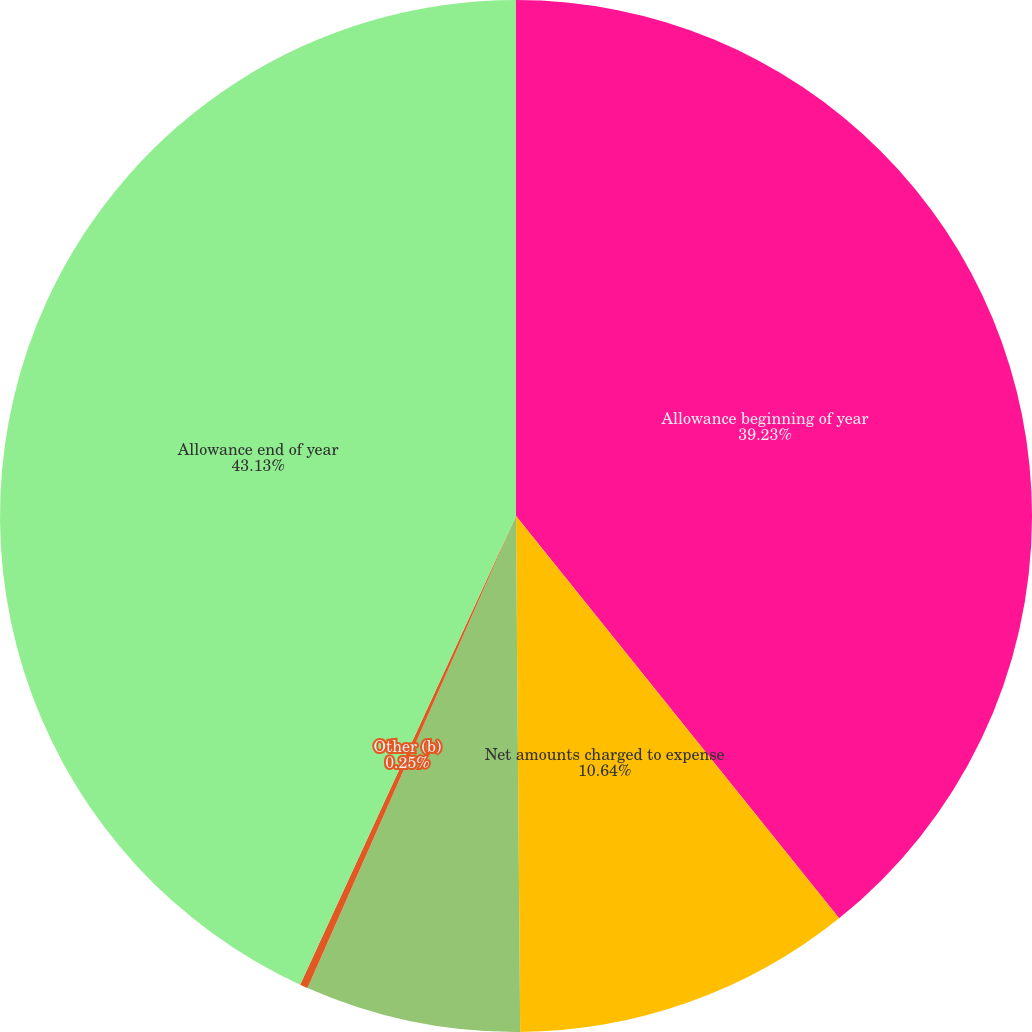Convert chart to OTSL. <chart><loc_0><loc_0><loc_500><loc_500><pie_chart><fcel>Allowance beginning of year<fcel>Net amounts charged to expense<fcel>Deductions (a)<fcel>Other (b)<fcel>Allowance end of year<nl><fcel>39.23%<fcel>10.64%<fcel>6.75%<fcel>0.25%<fcel>43.13%<nl></chart> 